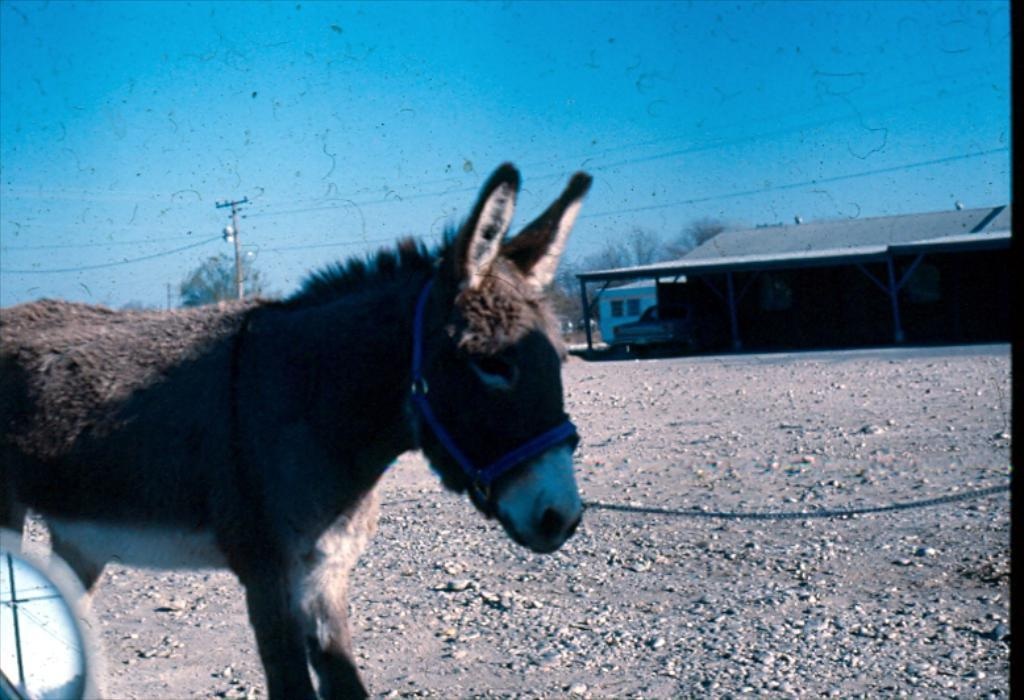What animal is present in the image? There is a horse in the image. What structures or objects can be seen in the background of the image? There is a utility pole, a building, and trees in the background of the image. What part of the natural environment is visible in the image? The sky is visible in the background of the image. What time of day is it in the image, specifically in the afternoon? The time of day is not specified in the image, and there is no indication of the afternoon. 